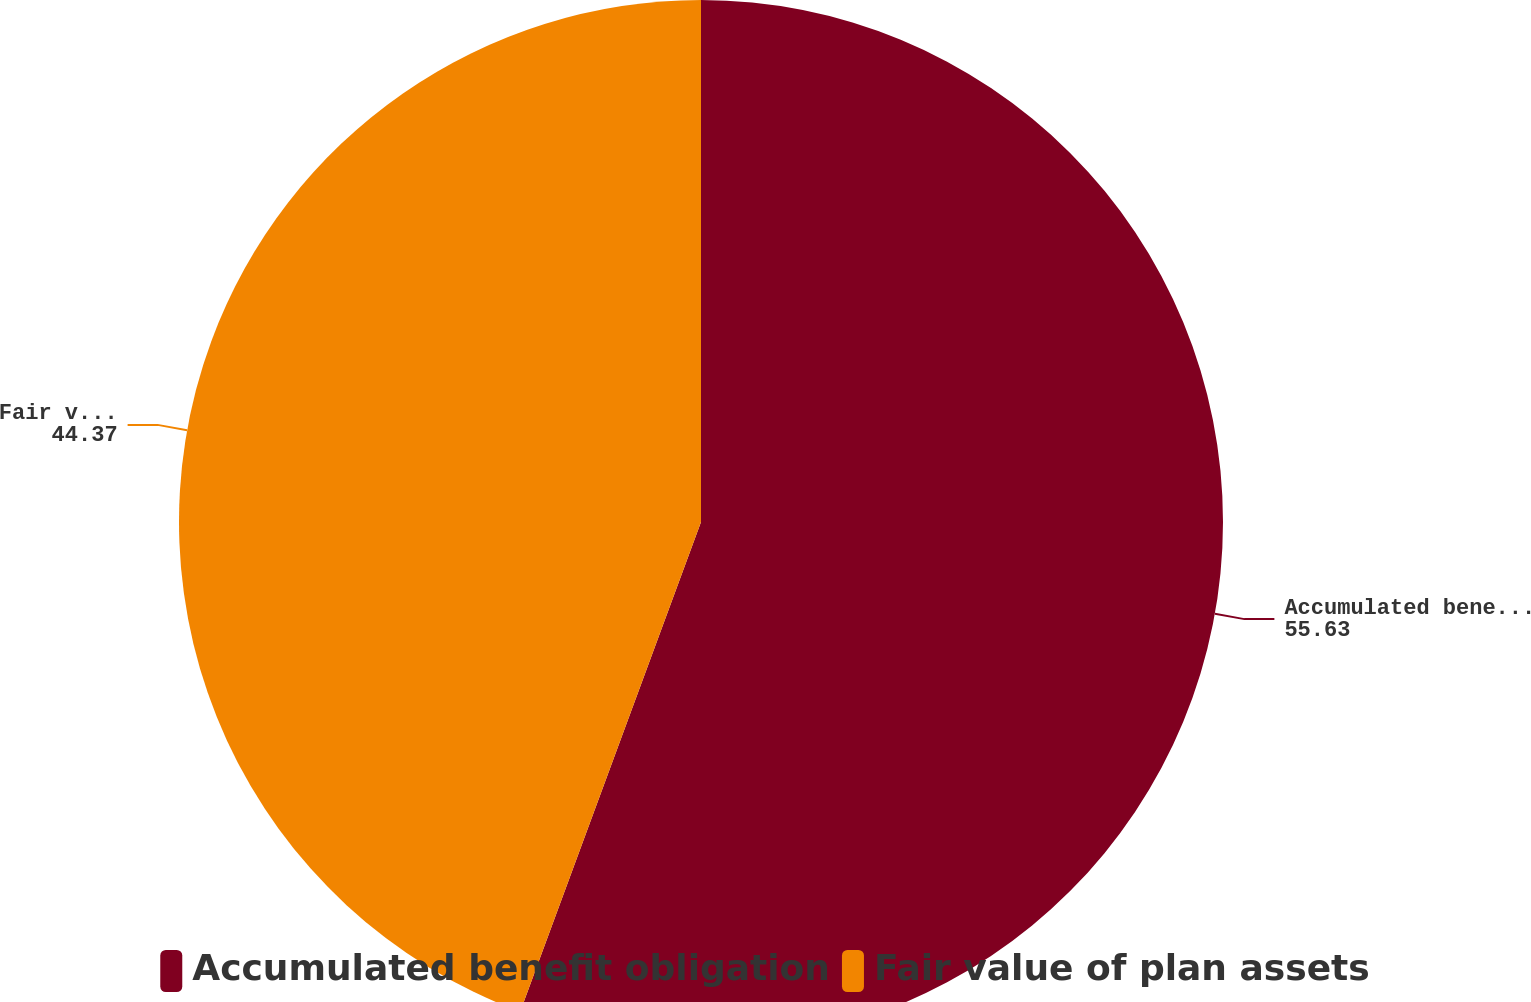Convert chart to OTSL. <chart><loc_0><loc_0><loc_500><loc_500><pie_chart><fcel>Accumulated benefit obligation<fcel>Fair value of plan assets<nl><fcel>55.63%<fcel>44.37%<nl></chart> 